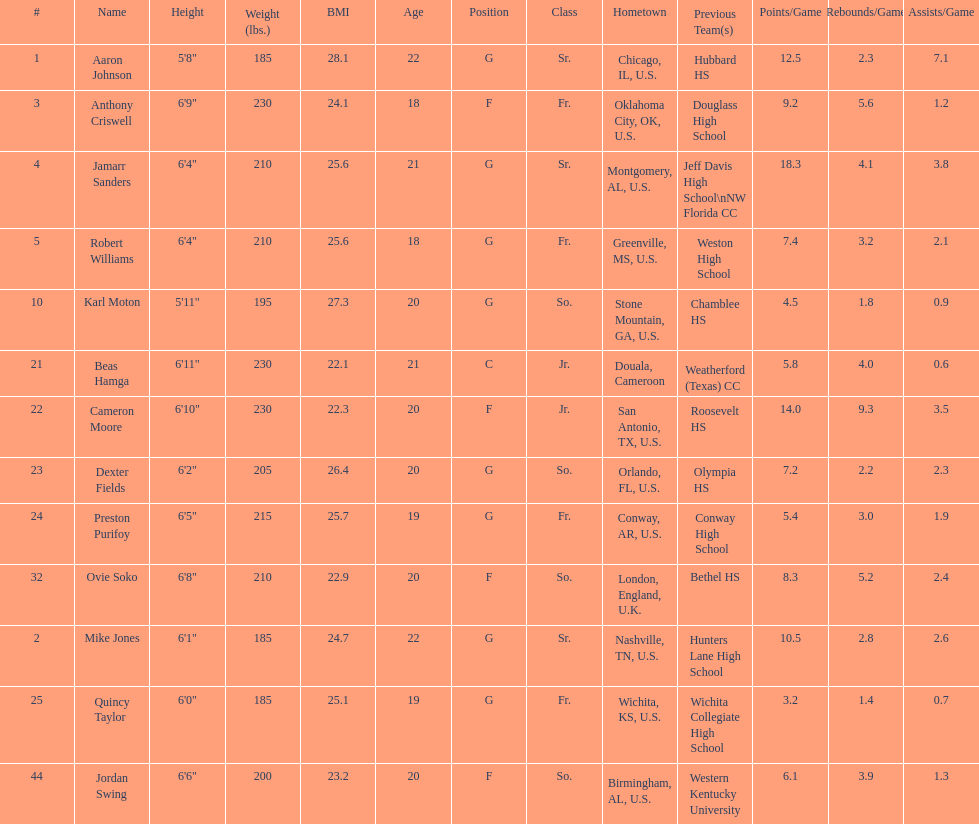How many players were on the 2010-11 uab blazers men's basketball team? 13. 